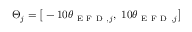Convert formula to latex. <formula><loc_0><loc_0><loc_500><loc_500>\Theta _ { j } = \left [ - 1 0 \theta _ { E F D , j } , 1 0 \theta _ { E F D , j } \right ]</formula> 